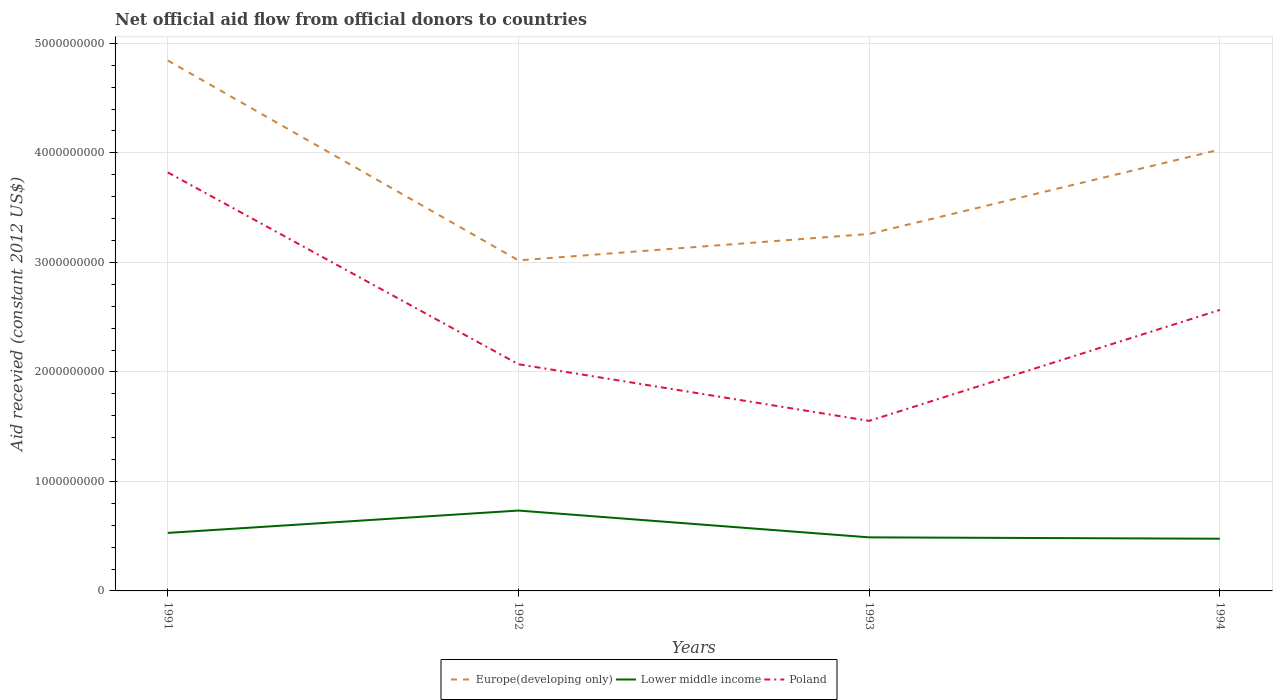Across all years, what is the maximum total aid received in Poland?
Provide a short and direct response. 1.55e+09. In which year was the total aid received in Europe(developing only) maximum?
Provide a succinct answer. 1992. What is the total total aid received in Lower middle income in the graph?
Ensure brevity in your answer.  4.06e+07. What is the difference between the highest and the second highest total aid received in Europe(developing only)?
Your answer should be very brief. 1.83e+09. Is the total aid received in Poland strictly greater than the total aid received in Lower middle income over the years?
Give a very brief answer. No. Does the graph contain any zero values?
Offer a very short reply. No. Does the graph contain grids?
Your response must be concise. Yes. Where does the legend appear in the graph?
Your answer should be compact. Bottom center. How many legend labels are there?
Make the answer very short. 3. What is the title of the graph?
Give a very brief answer. Net official aid flow from official donors to countries. Does "Nigeria" appear as one of the legend labels in the graph?
Your answer should be very brief. No. What is the label or title of the Y-axis?
Keep it short and to the point. Aid recevied (constant 2012 US$). What is the Aid recevied (constant 2012 US$) of Europe(developing only) in 1991?
Your answer should be compact. 4.84e+09. What is the Aid recevied (constant 2012 US$) in Lower middle income in 1991?
Ensure brevity in your answer.  5.30e+08. What is the Aid recevied (constant 2012 US$) of Poland in 1991?
Give a very brief answer. 3.82e+09. What is the Aid recevied (constant 2012 US$) of Europe(developing only) in 1992?
Keep it short and to the point. 3.02e+09. What is the Aid recevied (constant 2012 US$) of Lower middle income in 1992?
Your answer should be very brief. 7.34e+08. What is the Aid recevied (constant 2012 US$) in Poland in 1992?
Make the answer very short. 2.07e+09. What is the Aid recevied (constant 2012 US$) of Europe(developing only) in 1993?
Offer a very short reply. 3.26e+09. What is the Aid recevied (constant 2012 US$) in Lower middle income in 1993?
Provide a succinct answer. 4.89e+08. What is the Aid recevied (constant 2012 US$) in Poland in 1993?
Your answer should be compact. 1.55e+09. What is the Aid recevied (constant 2012 US$) of Europe(developing only) in 1994?
Offer a very short reply. 4.03e+09. What is the Aid recevied (constant 2012 US$) in Lower middle income in 1994?
Give a very brief answer. 4.77e+08. What is the Aid recevied (constant 2012 US$) of Poland in 1994?
Ensure brevity in your answer.  2.57e+09. Across all years, what is the maximum Aid recevied (constant 2012 US$) of Europe(developing only)?
Provide a short and direct response. 4.84e+09. Across all years, what is the maximum Aid recevied (constant 2012 US$) in Lower middle income?
Offer a terse response. 7.34e+08. Across all years, what is the maximum Aid recevied (constant 2012 US$) in Poland?
Your answer should be very brief. 3.82e+09. Across all years, what is the minimum Aid recevied (constant 2012 US$) of Europe(developing only)?
Your answer should be compact. 3.02e+09. Across all years, what is the minimum Aid recevied (constant 2012 US$) of Lower middle income?
Your response must be concise. 4.77e+08. Across all years, what is the minimum Aid recevied (constant 2012 US$) in Poland?
Keep it short and to the point. 1.55e+09. What is the total Aid recevied (constant 2012 US$) in Europe(developing only) in the graph?
Your answer should be compact. 1.52e+1. What is the total Aid recevied (constant 2012 US$) of Lower middle income in the graph?
Your answer should be compact. 2.23e+09. What is the total Aid recevied (constant 2012 US$) in Poland in the graph?
Keep it short and to the point. 1.00e+1. What is the difference between the Aid recevied (constant 2012 US$) in Europe(developing only) in 1991 and that in 1992?
Offer a terse response. 1.83e+09. What is the difference between the Aid recevied (constant 2012 US$) of Lower middle income in 1991 and that in 1992?
Offer a terse response. -2.04e+08. What is the difference between the Aid recevied (constant 2012 US$) of Poland in 1991 and that in 1992?
Make the answer very short. 1.75e+09. What is the difference between the Aid recevied (constant 2012 US$) of Europe(developing only) in 1991 and that in 1993?
Offer a terse response. 1.58e+09. What is the difference between the Aid recevied (constant 2012 US$) in Lower middle income in 1991 and that in 1993?
Keep it short and to the point. 4.06e+07. What is the difference between the Aid recevied (constant 2012 US$) of Poland in 1991 and that in 1993?
Keep it short and to the point. 2.27e+09. What is the difference between the Aid recevied (constant 2012 US$) of Europe(developing only) in 1991 and that in 1994?
Make the answer very short. 8.13e+08. What is the difference between the Aid recevied (constant 2012 US$) of Lower middle income in 1991 and that in 1994?
Provide a succinct answer. 5.31e+07. What is the difference between the Aid recevied (constant 2012 US$) in Poland in 1991 and that in 1994?
Your response must be concise. 1.26e+09. What is the difference between the Aid recevied (constant 2012 US$) of Europe(developing only) in 1992 and that in 1993?
Offer a very short reply. -2.41e+08. What is the difference between the Aid recevied (constant 2012 US$) in Lower middle income in 1992 and that in 1993?
Your response must be concise. 2.45e+08. What is the difference between the Aid recevied (constant 2012 US$) in Poland in 1992 and that in 1993?
Keep it short and to the point. 5.17e+08. What is the difference between the Aid recevied (constant 2012 US$) of Europe(developing only) in 1992 and that in 1994?
Your answer should be compact. -1.01e+09. What is the difference between the Aid recevied (constant 2012 US$) in Lower middle income in 1992 and that in 1994?
Offer a terse response. 2.57e+08. What is the difference between the Aid recevied (constant 2012 US$) in Poland in 1992 and that in 1994?
Keep it short and to the point. -4.96e+08. What is the difference between the Aid recevied (constant 2012 US$) of Europe(developing only) in 1993 and that in 1994?
Provide a short and direct response. -7.71e+08. What is the difference between the Aid recevied (constant 2012 US$) in Lower middle income in 1993 and that in 1994?
Keep it short and to the point. 1.25e+07. What is the difference between the Aid recevied (constant 2012 US$) in Poland in 1993 and that in 1994?
Give a very brief answer. -1.01e+09. What is the difference between the Aid recevied (constant 2012 US$) of Europe(developing only) in 1991 and the Aid recevied (constant 2012 US$) of Lower middle income in 1992?
Ensure brevity in your answer.  4.11e+09. What is the difference between the Aid recevied (constant 2012 US$) in Europe(developing only) in 1991 and the Aid recevied (constant 2012 US$) in Poland in 1992?
Offer a very short reply. 2.77e+09. What is the difference between the Aid recevied (constant 2012 US$) in Lower middle income in 1991 and the Aid recevied (constant 2012 US$) in Poland in 1992?
Provide a succinct answer. -1.54e+09. What is the difference between the Aid recevied (constant 2012 US$) of Europe(developing only) in 1991 and the Aid recevied (constant 2012 US$) of Lower middle income in 1993?
Give a very brief answer. 4.35e+09. What is the difference between the Aid recevied (constant 2012 US$) in Europe(developing only) in 1991 and the Aid recevied (constant 2012 US$) in Poland in 1993?
Ensure brevity in your answer.  3.29e+09. What is the difference between the Aid recevied (constant 2012 US$) in Lower middle income in 1991 and the Aid recevied (constant 2012 US$) in Poland in 1993?
Provide a short and direct response. -1.02e+09. What is the difference between the Aid recevied (constant 2012 US$) in Europe(developing only) in 1991 and the Aid recevied (constant 2012 US$) in Lower middle income in 1994?
Give a very brief answer. 4.37e+09. What is the difference between the Aid recevied (constant 2012 US$) of Europe(developing only) in 1991 and the Aid recevied (constant 2012 US$) of Poland in 1994?
Your response must be concise. 2.28e+09. What is the difference between the Aid recevied (constant 2012 US$) of Lower middle income in 1991 and the Aid recevied (constant 2012 US$) of Poland in 1994?
Offer a terse response. -2.04e+09. What is the difference between the Aid recevied (constant 2012 US$) of Europe(developing only) in 1992 and the Aid recevied (constant 2012 US$) of Lower middle income in 1993?
Your answer should be very brief. 2.53e+09. What is the difference between the Aid recevied (constant 2012 US$) in Europe(developing only) in 1992 and the Aid recevied (constant 2012 US$) in Poland in 1993?
Your response must be concise. 1.47e+09. What is the difference between the Aid recevied (constant 2012 US$) of Lower middle income in 1992 and the Aid recevied (constant 2012 US$) of Poland in 1993?
Ensure brevity in your answer.  -8.19e+08. What is the difference between the Aid recevied (constant 2012 US$) of Europe(developing only) in 1992 and the Aid recevied (constant 2012 US$) of Lower middle income in 1994?
Ensure brevity in your answer.  2.54e+09. What is the difference between the Aid recevied (constant 2012 US$) of Europe(developing only) in 1992 and the Aid recevied (constant 2012 US$) of Poland in 1994?
Your answer should be compact. 4.52e+08. What is the difference between the Aid recevied (constant 2012 US$) of Lower middle income in 1992 and the Aid recevied (constant 2012 US$) of Poland in 1994?
Provide a succinct answer. -1.83e+09. What is the difference between the Aid recevied (constant 2012 US$) of Europe(developing only) in 1993 and the Aid recevied (constant 2012 US$) of Lower middle income in 1994?
Your answer should be compact. 2.78e+09. What is the difference between the Aid recevied (constant 2012 US$) of Europe(developing only) in 1993 and the Aid recevied (constant 2012 US$) of Poland in 1994?
Offer a terse response. 6.94e+08. What is the difference between the Aid recevied (constant 2012 US$) in Lower middle income in 1993 and the Aid recevied (constant 2012 US$) in Poland in 1994?
Ensure brevity in your answer.  -2.08e+09. What is the average Aid recevied (constant 2012 US$) in Europe(developing only) per year?
Your answer should be very brief. 3.79e+09. What is the average Aid recevied (constant 2012 US$) of Lower middle income per year?
Provide a succinct answer. 5.57e+08. What is the average Aid recevied (constant 2012 US$) in Poland per year?
Give a very brief answer. 2.50e+09. In the year 1991, what is the difference between the Aid recevied (constant 2012 US$) in Europe(developing only) and Aid recevied (constant 2012 US$) in Lower middle income?
Ensure brevity in your answer.  4.31e+09. In the year 1991, what is the difference between the Aid recevied (constant 2012 US$) of Europe(developing only) and Aid recevied (constant 2012 US$) of Poland?
Your response must be concise. 1.02e+09. In the year 1991, what is the difference between the Aid recevied (constant 2012 US$) of Lower middle income and Aid recevied (constant 2012 US$) of Poland?
Ensure brevity in your answer.  -3.29e+09. In the year 1992, what is the difference between the Aid recevied (constant 2012 US$) of Europe(developing only) and Aid recevied (constant 2012 US$) of Lower middle income?
Your answer should be compact. 2.28e+09. In the year 1992, what is the difference between the Aid recevied (constant 2012 US$) of Europe(developing only) and Aid recevied (constant 2012 US$) of Poland?
Make the answer very short. 9.49e+08. In the year 1992, what is the difference between the Aid recevied (constant 2012 US$) of Lower middle income and Aid recevied (constant 2012 US$) of Poland?
Provide a succinct answer. -1.34e+09. In the year 1993, what is the difference between the Aid recevied (constant 2012 US$) of Europe(developing only) and Aid recevied (constant 2012 US$) of Lower middle income?
Keep it short and to the point. 2.77e+09. In the year 1993, what is the difference between the Aid recevied (constant 2012 US$) of Europe(developing only) and Aid recevied (constant 2012 US$) of Poland?
Provide a succinct answer. 1.71e+09. In the year 1993, what is the difference between the Aid recevied (constant 2012 US$) of Lower middle income and Aid recevied (constant 2012 US$) of Poland?
Provide a succinct answer. -1.06e+09. In the year 1994, what is the difference between the Aid recevied (constant 2012 US$) of Europe(developing only) and Aid recevied (constant 2012 US$) of Lower middle income?
Keep it short and to the point. 3.55e+09. In the year 1994, what is the difference between the Aid recevied (constant 2012 US$) of Europe(developing only) and Aid recevied (constant 2012 US$) of Poland?
Provide a succinct answer. 1.46e+09. In the year 1994, what is the difference between the Aid recevied (constant 2012 US$) of Lower middle income and Aid recevied (constant 2012 US$) of Poland?
Provide a succinct answer. -2.09e+09. What is the ratio of the Aid recevied (constant 2012 US$) of Europe(developing only) in 1991 to that in 1992?
Keep it short and to the point. 1.6. What is the ratio of the Aid recevied (constant 2012 US$) of Lower middle income in 1991 to that in 1992?
Offer a terse response. 0.72. What is the ratio of the Aid recevied (constant 2012 US$) in Poland in 1991 to that in 1992?
Your answer should be compact. 1.85. What is the ratio of the Aid recevied (constant 2012 US$) of Europe(developing only) in 1991 to that in 1993?
Your response must be concise. 1.49. What is the ratio of the Aid recevied (constant 2012 US$) in Lower middle income in 1991 to that in 1993?
Ensure brevity in your answer.  1.08. What is the ratio of the Aid recevied (constant 2012 US$) in Poland in 1991 to that in 1993?
Ensure brevity in your answer.  2.46. What is the ratio of the Aid recevied (constant 2012 US$) in Europe(developing only) in 1991 to that in 1994?
Make the answer very short. 1.2. What is the ratio of the Aid recevied (constant 2012 US$) in Lower middle income in 1991 to that in 1994?
Ensure brevity in your answer.  1.11. What is the ratio of the Aid recevied (constant 2012 US$) of Poland in 1991 to that in 1994?
Your answer should be compact. 1.49. What is the ratio of the Aid recevied (constant 2012 US$) in Europe(developing only) in 1992 to that in 1993?
Ensure brevity in your answer.  0.93. What is the ratio of the Aid recevied (constant 2012 US$) in Lower middle income in 1992 to that in 1993?
Your answer should be very brief. 1.5. What is the ratio of the Aid recevied (constant 2012 US$) in Poland in 1992 to that in 1993?
Provide a short and direct response. 1.33. What is the ratio of the Aid recevied (constant 2012 US$) of Europe(developing only) in 1992 to that in 1994?
Keep it short and to the point. 0.75. What is the ratio of the Aid recevied (constant 2012 US$) in Lower middle income in 1992 to that in 1994?
Provide a short and direct response. 1.54. What is the ratio of the Aid recevied (constant 2012 US$) in Poland in 1992 to that in 1994?
Provide a succinct answer. 0.81. What is the ratio of the Aid recevied (constant 2012 US$) in Europe(developing only) in 1993 to that in 1994?
Your answer should be very brief. 0.81. What is the ratio of the Aid recevied (constant 2012 US$) of Lower middle income in 1993 to that in 1994?
Ensure brevity in your answer.  1.03. What is the ratio of the Aid recevied (constant 2012 US$) of Poland in 1993 to that in 1994?
Give a very brief answer. 0.61. What is the difference between the highest and the second highest Aid recevied (constant 2012 US$) of Europe(developing only)?
Make the answer very short. 8.13e+08. What is the difference between the highest and the second highest Aid recevied (constant 2012 US$) in Lower middle income?
Make the answer very short. 2.04e+08. What is the difference between the highest and the second highest Aid recevied (constant 2012 US$) of Poland?
Offer a very short reply. 1.26e+09. What is the difference between the highest and the lowest Aid recevied (constant 2012 US$) in Europe(developing only)?
Make the answer very short. 1.83e+09. What is the difference between the highest and the lowest Aid recevied (constant 2012 US$) of Lower middle income?
Give a very brief answer. 2.57e+08. What is the difference between the highest and the lowest Aid recevied (constant 2012 US$) of Poland?
Keep it short and to the point. 2.27e+09. 